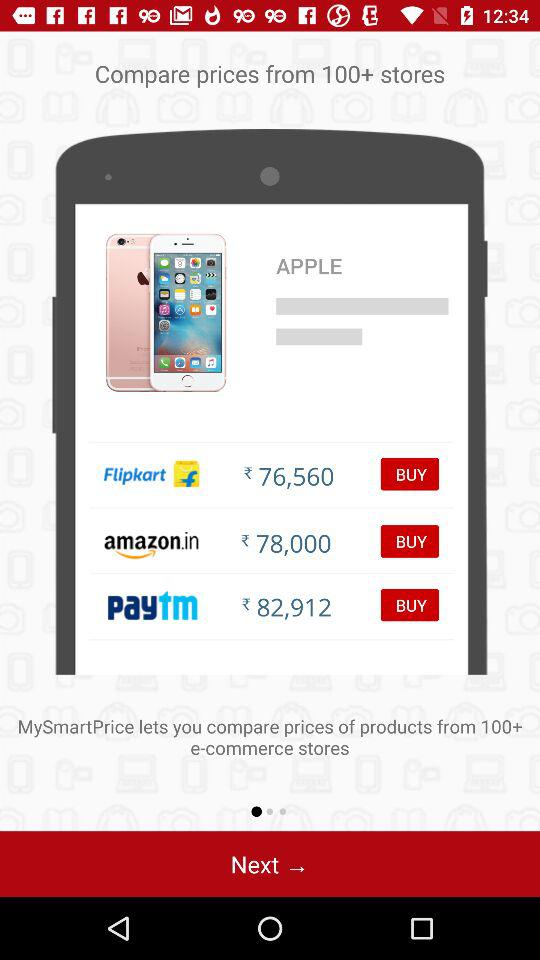What is the name of the application? The name of the application is "MySmartPrice". 